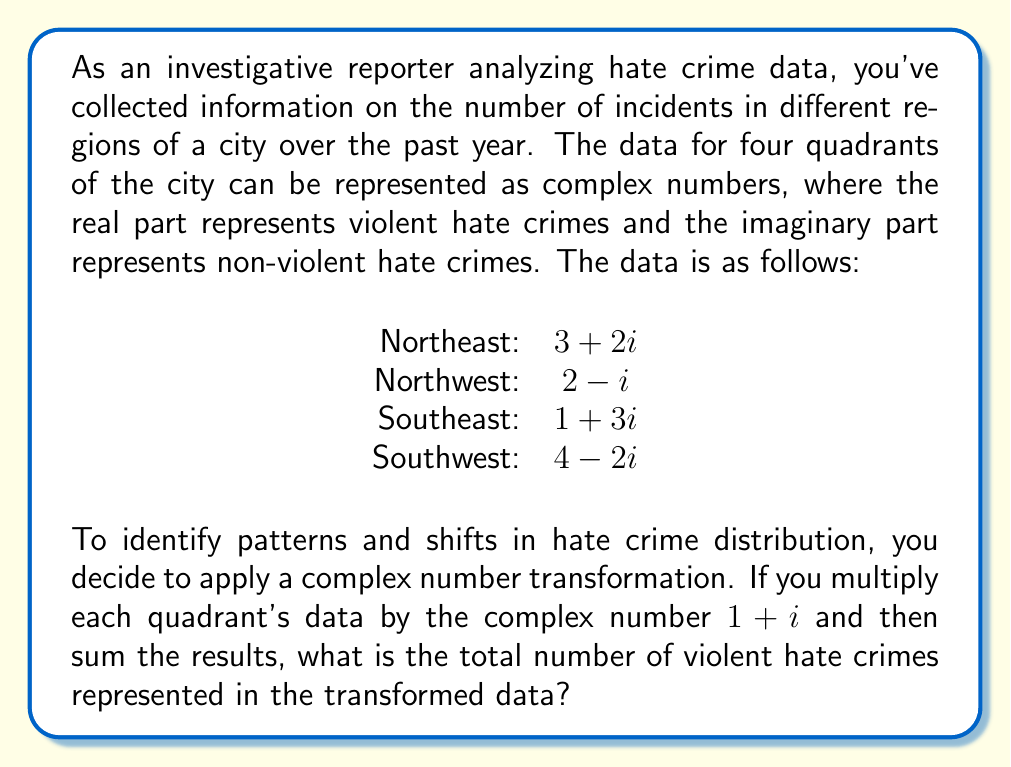Could you help me with this problem? Let's approach this step-by-step:

1) First, we need to multiply each quadrant's data by $1 + i$:

   Northeast: $(3 + 2i)(1 + i) = 3 + 3i + 2i + 2i^2 = 3 + 5i - 2 = 1 + 5i$
   Northwest: $(2 - i)(1 + i) = 2 + 2i - i - i^2 = 2 + 2i - i + 1 = 3 + i$
   Southeast: $(1 + 3i)(1 + i) = 1 + i + 3i + 3i^2 = 1 + 4i - 3 = -2 + 4i$
   Southwest: $(4 - 2i)(1 + i) = 4 + 4i - 2i - 2i^2 = 4 + 2i + 2 = 6 + 2i$

2) Now, we need to sum these transformed values:

   $(1 + 5i) + (3 + i) + (-2 + 4i) + (6 + 2i) = 8 + 12i$

3) The question asks for the total number of violent hate crimes in the transformed data. In a complex number, the real part represents the violent hate crimes.

4) Therefore, the answer is the real part of the sum: 8.
Answer: 8 